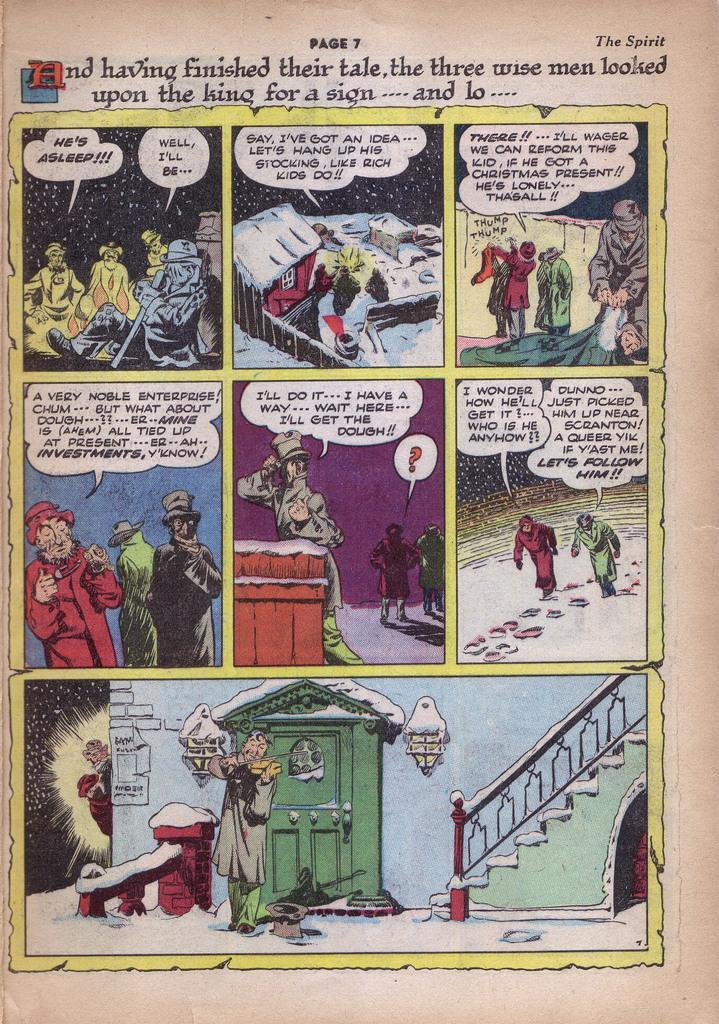<image>
Relay a brief, clear account of the picture shown. a page that says 'the spirit page 7' on the top of it 